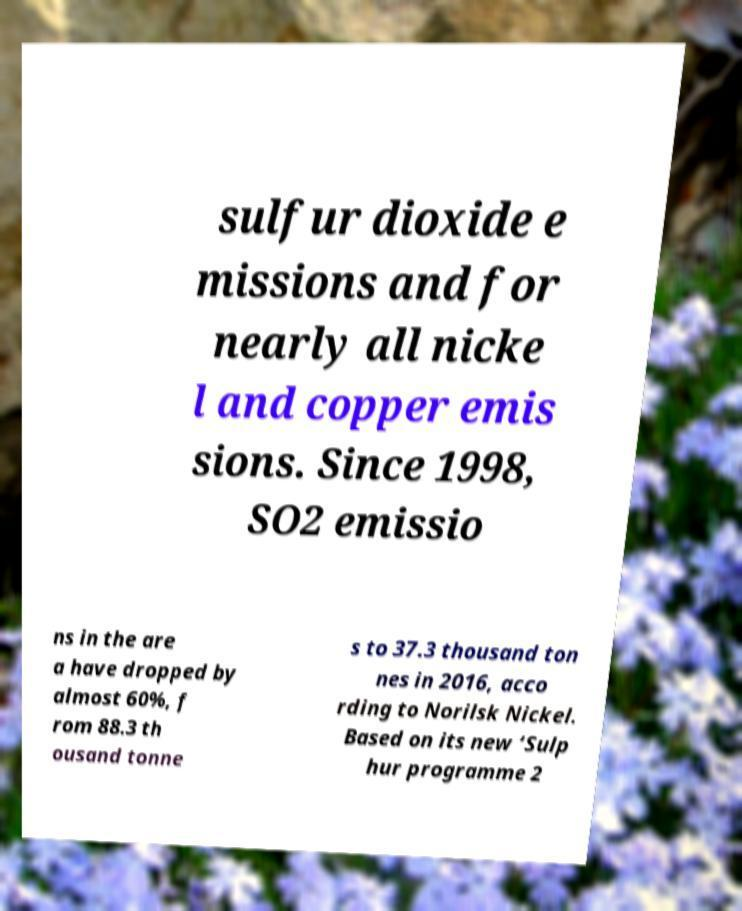Could you assist in decoding the text presented in this image and type it out clearly? sulfur dioxide e missions and for nearly all nicke l and copper emis sions. Since 1998, SO2 emissio ns in the are a have dropped by almost 60%, f rom 88.3 th ousand tonne s to 37.3 thousand ton nes in 2016, acco rding to Norilsk Nickel. Based on its new ‘Sulp hur programme 2 